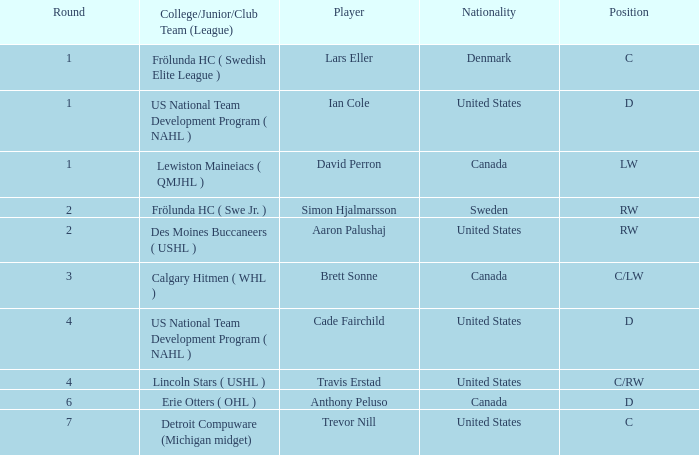Who is the player from Denmark who plays position c? Lars Eller. 